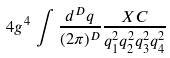<formula> <loc_0><loc_0><loc_500><loc_500>4 g ^ { 4 } \, \int \frac { d ^ { D } q } { ( 2 \pi ) ^ { D } } \frac { X C } { q _ { 1 } ^ { 2 } q _ { 2 } ^ { 2 } q _ { 3 } ^ { 2 } q _ { 4 } ^ { 2 } }</formula> 